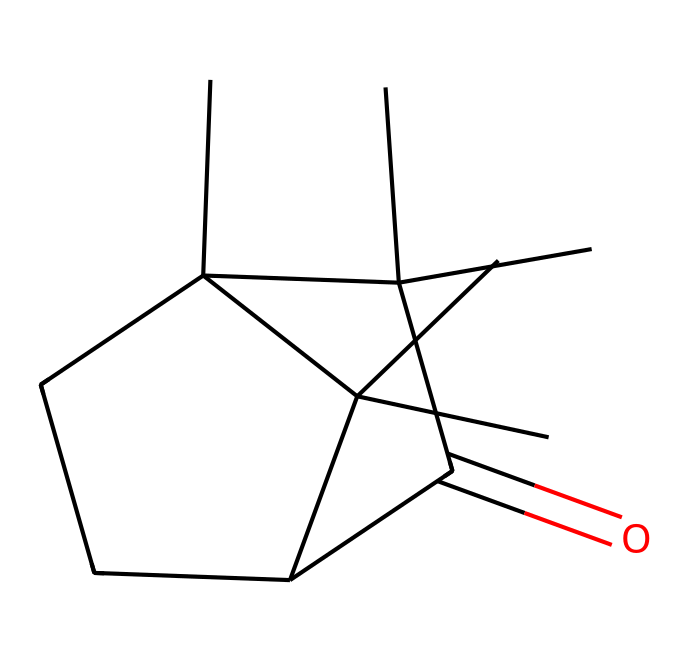What is the molecular formula of camphor? To determine the molecular formula, we can analyze the provided SMILES. The structure reveals 10 carbon (C) atoms, 16 hydrogen (H) atoms, and 1 oxygen (O) atom, leading to the formula C10H16O.
Answer: C10H16O How many rings are present in camphor? By examining the structure in the SMILES notation, we can identify that there are two distinct cycloalkane rings indicated by the numbers '1' and '2', suggesting that camphor contains 2 rings.
Answer: 2 What type of functional group is found in camphor? The presence of the carbonyl group (C=O) in the structure indicates that camphor has a ketone functional group, which is characteristic of ketones.
Answer: ketone What is the main characteristic feature of ketones in the provided structure? Ketones are defined by the presence of a carbonyl group (C=O) bonded to two carbon atoms. In the structure of camphor, the carbonyl group is readily identifiable, confirming its classification as a ketone.
Answer: carbonyl group Is camphor a saturated or unsaturated compound? The presence of double bonds, indicated by the carbonyl group and the structure’s overall carbon connectivity, suggests that camphor is not fully saturated with hydrogen. Therefore, it is classified as an unsaturated compound due to the presence of the carbonyl group.
Answer: unsaturated What is the total number of hydrogen atoms in camphor? By counting the hydrogen atoms directly from the molecular formula derived from the structure, we confirm that camphor has a total of 16 hydrogen atoms.
Answer: 16 